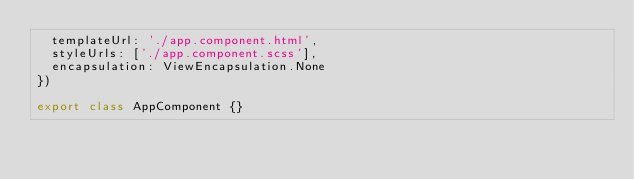Convert code to text. <code><loc_0><loc_0><loc_500><loc_500><_TypeScript_>  templateUrl: './app.component.html',
  styleUrls: ['./app.component.scss'],
  encapsulation: ViewEncapsulation.None
})

export class AppComponent {}
</code> 